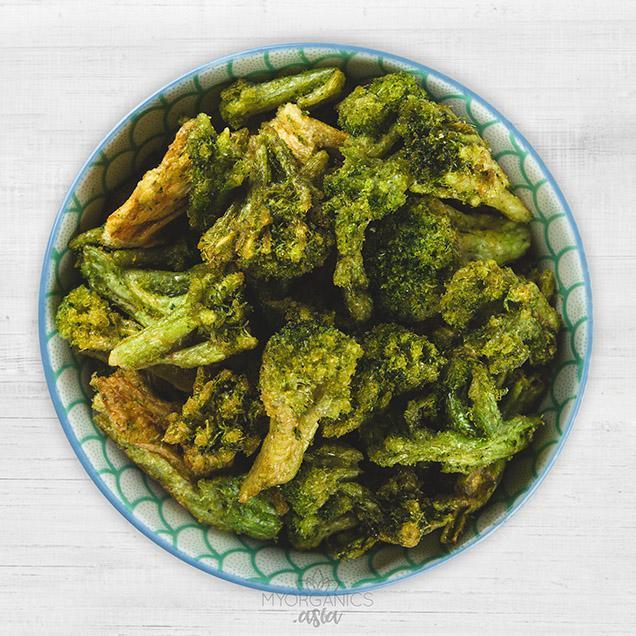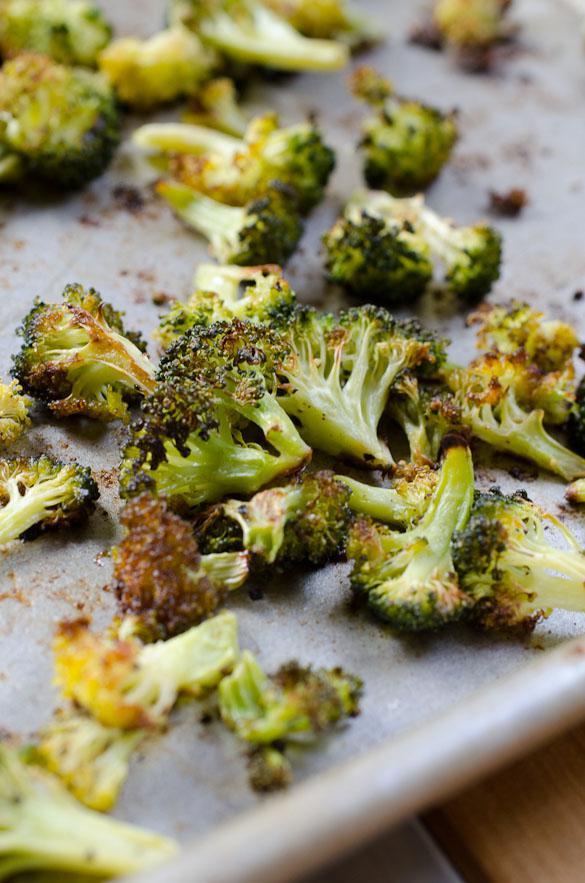The first image is the image on the left, the second image is the image on the right. Considering the images on both sides, is "The food in the right image is in a solid white bowl." valid? Answer yes or no. No. The first image is the image on the left, the second image is the image on the right. For the images shown, is this caption "There are two bowls of broccoli." true? Answer yes or no. No. 